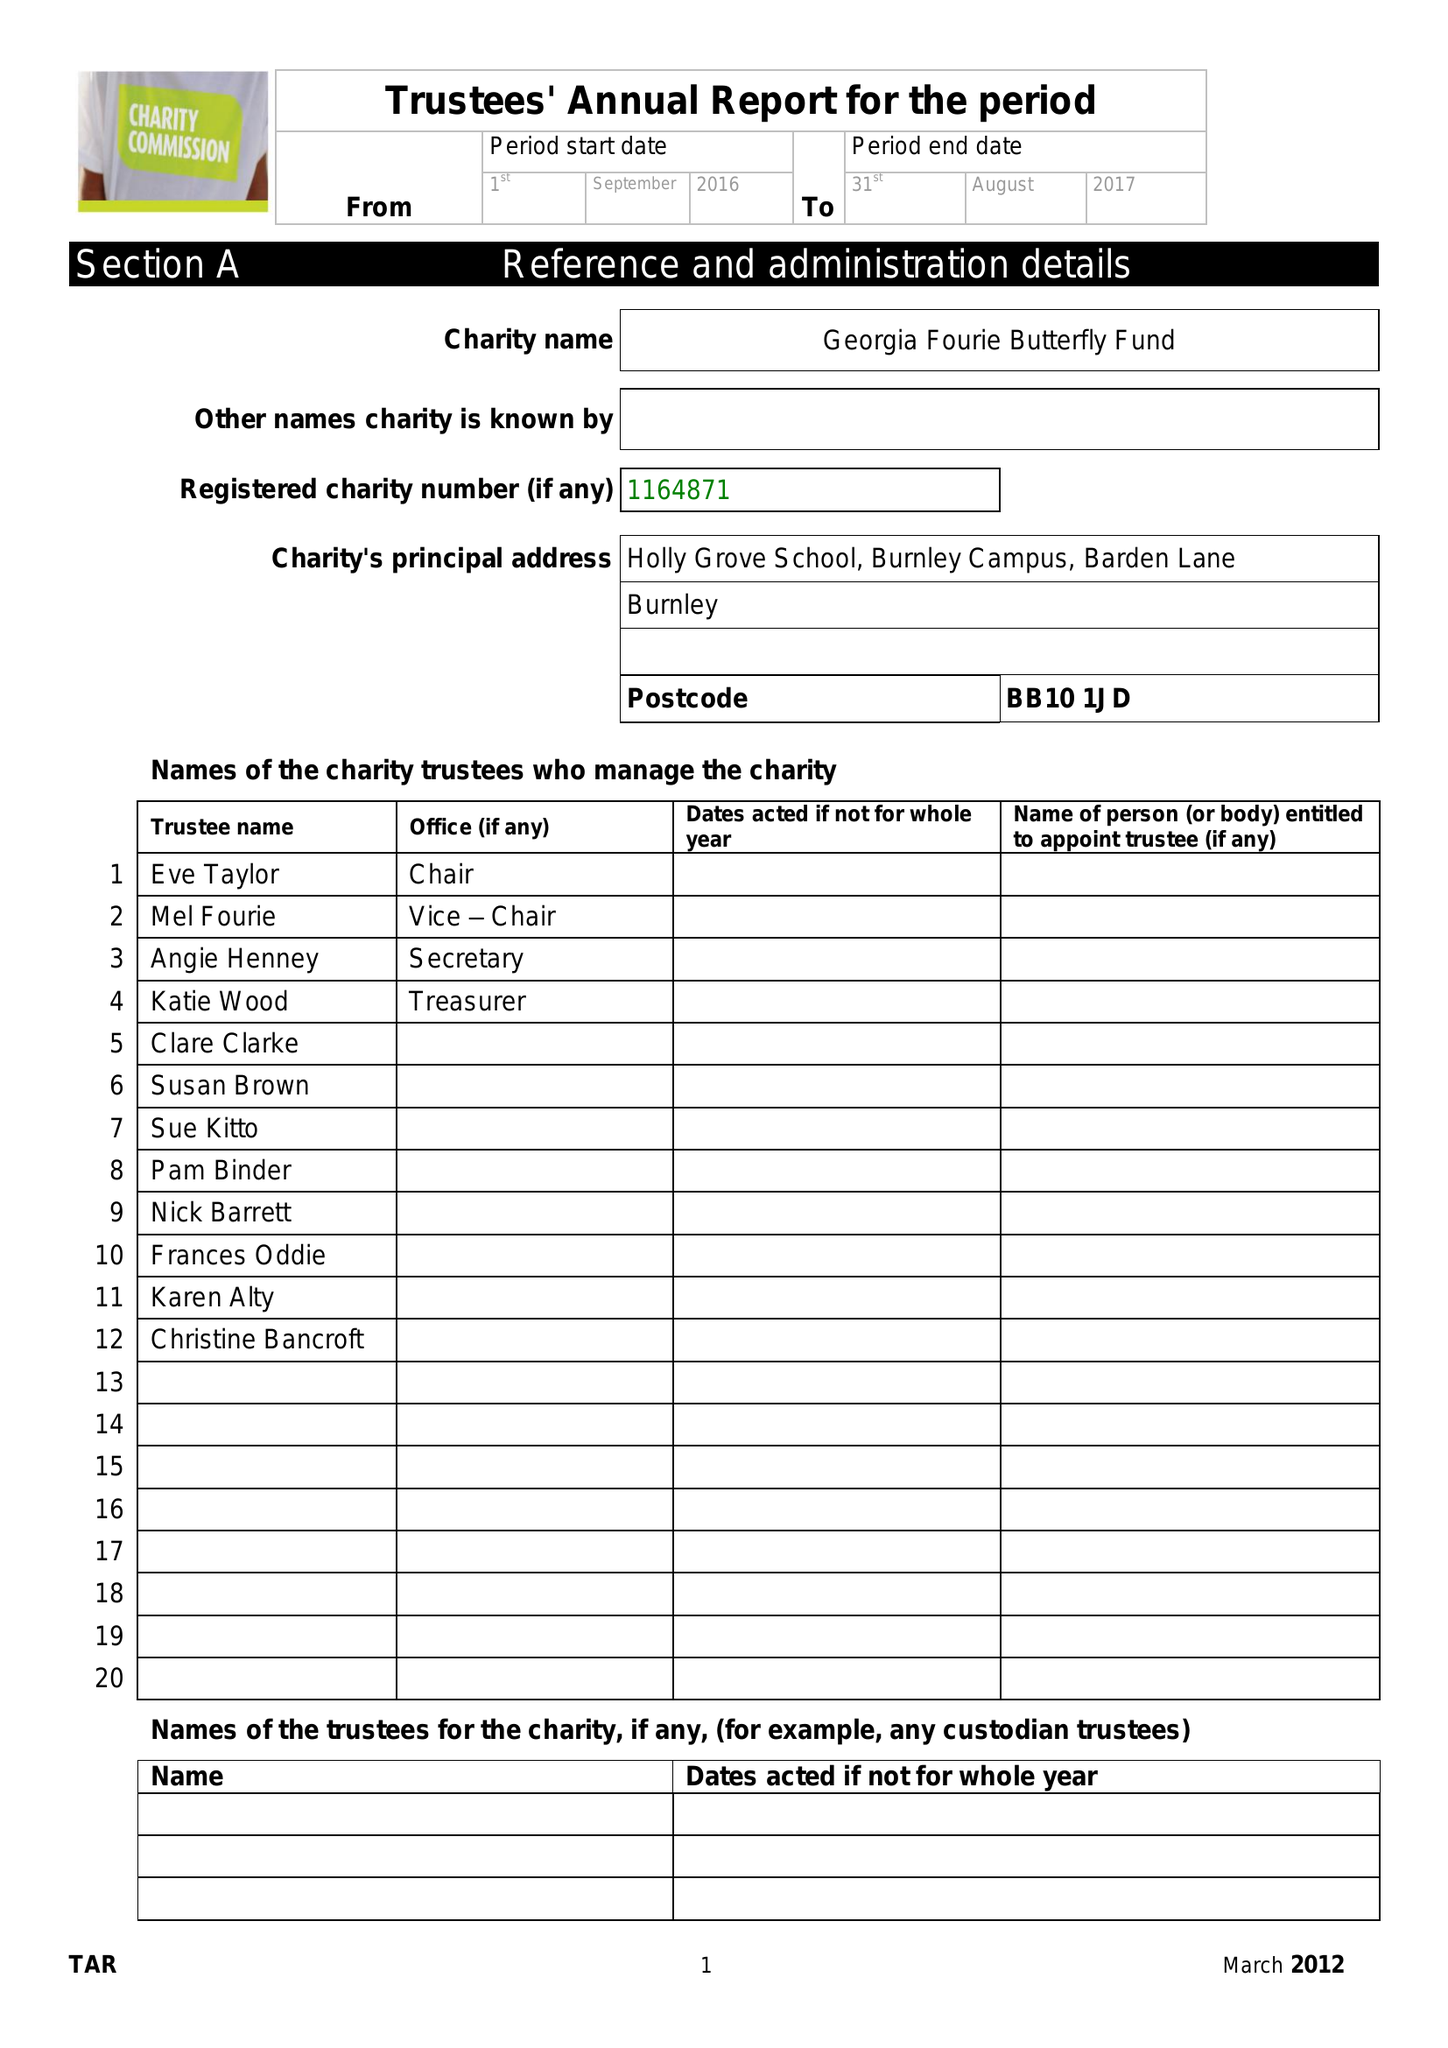What is the value for the charity_name?
Answer the question using a single word or phrase. The Georgia Fourie Butterfly Fund 